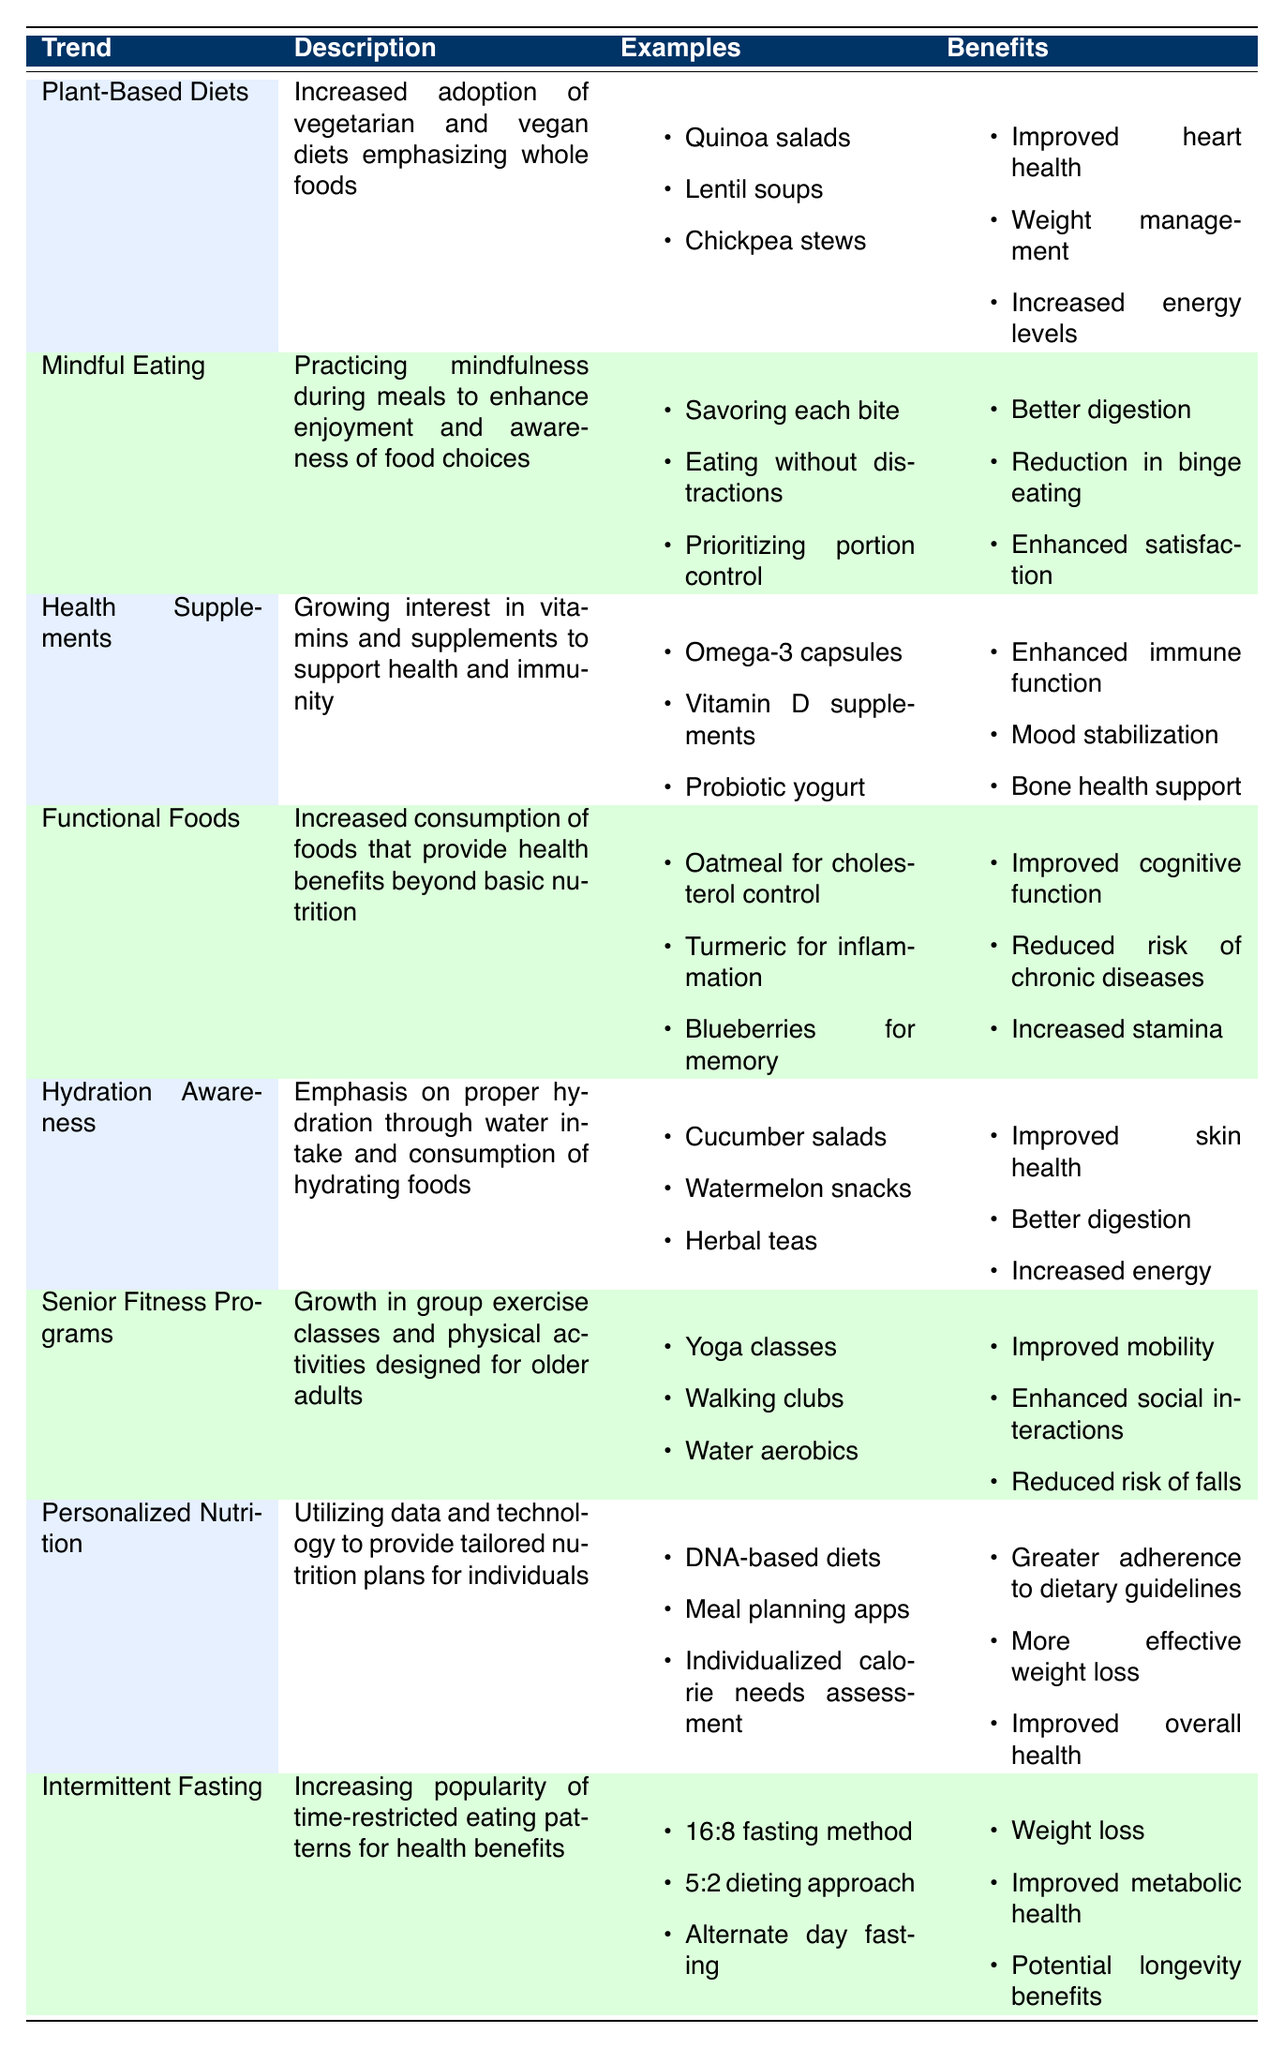What are some examples of Plant-Based Diets? The table lists three examples of Plant-Based Diets: Quinoa salads, Lentil soups, and Chickpea stews.
Answer: Quinoa salads, Lentil soups, Chickpea stews What are the benefits of Mindful Eating? According to the table, the benefits of Mindful Eating include better digestion, reduction in binge eating, and enhanced satisfaction.
Answer: Better digestion, reduction in binge eating, enhanced satisfaction Is Hydration Awareness focused only on drinking water? No, the description states that Hydration Awareness emphasizes both water intake and the consumption of hydrating foods, which include cucumber salads, watermelon snacks, and herbal teas.
Answer: No Which trend focuses on personalized nutrition plans? The trend that focuses on personalized nutrition plans is called Personalized Nutrition, as it utilizes data and technology to provide tailored nutrition plans.
Answer: Personalized Nutrition How many benefits does Intermittent Fasting claim to provide, and name one? The table indicates that Intermittent Fasting lists three benefits: weight loss, improved metabolic health, and potential longevity benefits. Therefore, it provides three benefits and one example is weight loss.
Answer: Three benefits; weight loss Which two trends offer benefits related to cognitive function? By examining the table, Functional Foods and Personalized Nutrition both mention improved cognitive function as a benefit. This can be seen in their respective benefit lists.
Answer: Functional Foods, Personalized Nutrition Are the examples of Health Supplements more about food or capsules? The examples listed for Health Supplements include Omega-3 capsules, Vitamin D supplements, and Probiotic yogurt, which indicates that they primarily focus on both capsules and food items.
Answer: No, they focus on both capsules and food items What is the main emphasis of Senior Fitness Programs? Senior Fitness Programs emphasize the growth of group exercise classes and physical activities designed specifically for older adults, which points to an increased focus on physical activity for this demographic.
Answer: Group exercise for older adults 